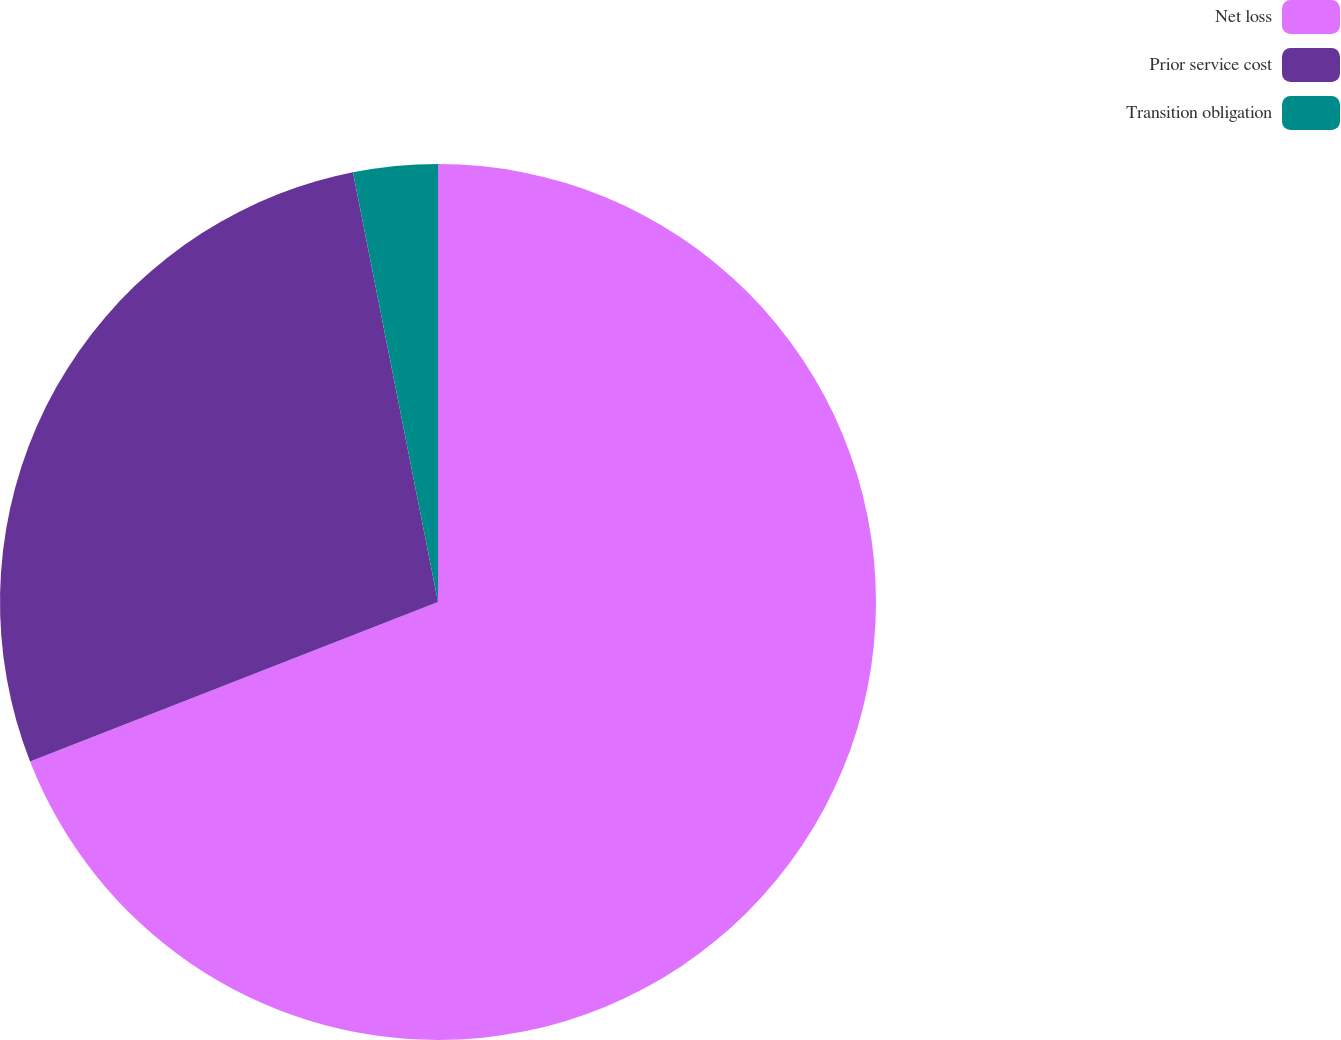<chart> <loc_0><loc_0><loc_500><loc_500><pie_chart><fcel>Net loss<fcel>Prior service cost<fcel>Transition obligation<nl><fcel>69.07%<fcel>27.82%<fcel>3.11%<nl></chart> 